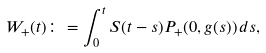Convert formula to latex. <formula><loc_0><loc_0><loc_500><loc_500>W _ { + } ( t ) \colon = \int _ { 0 } ^ { t } S ( t - s ) P _ { + } ( 0 , g ( s ) ) \, d s ,</formula> 